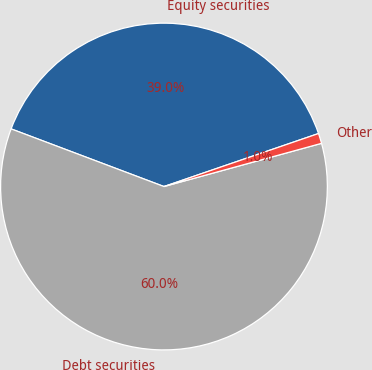Convert chart to OTSL. <chart><loc_0><loc_0><loc_500><loc_500><pie_chart><fcel>Equity securities<fcel>Debt securities<fcel>Other<nl><fcel>39.0%<fcel>60.0%<fcel>1.0%<nl></chart> 